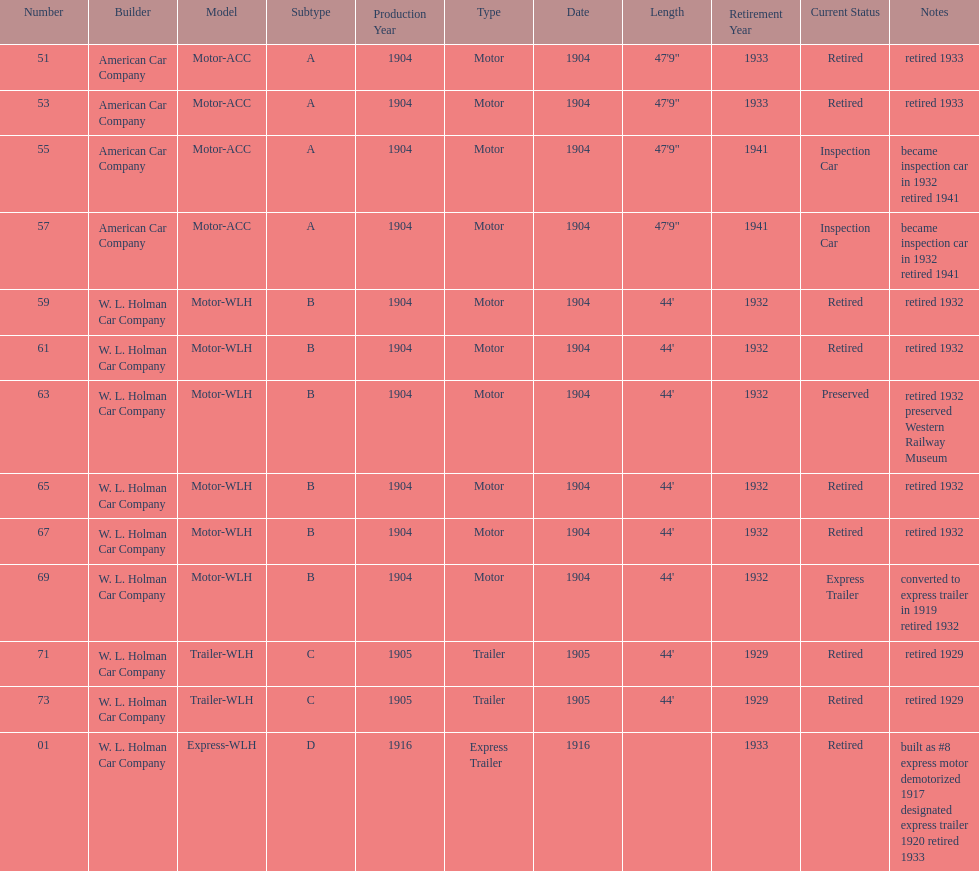Could you parse the entire table? {'header': ['Number', 'Builder', 'Model', 'Subtype', 'Production Year', 'Type', 'Date', 'Length', 'Retirement Year', 'Current Status', 'Notes'], 'rows': [['51', 'American Car Company', 'Motor-ACC', 'A', '1904', 'Motor', '1904', '47\'9"', '1933', 'Retired', 'retired 1933'], ['53', 'American Car Company', 'Motor-ACC', 'A', '1904', 'Motor', '1904', '47\'9"', '1933', 'Retired', 'retired 1933'], ['55', 'American Car Company', 'Motor-ACC', 'A', '1904', 'Motor', '1904', '47\'9"', '1941', 'Inspection Car', 'became inspection car in 1932 retired 1941'], ['57', 'American Car Company', 'Motor-ACC', 'A', '1904', 'Motor', '1904', '47\'9"', '1941', 'Inspection Car', 'became inspection car in 1932 retired 1941'], ['59', 'W. L. Holman Car Company', 'Motor-WLH', 'B', '1904', 'Motor', '1904', "44'", '1932', 'Retired', 'retired 1932'], ['61', 'W. L. Holman Car Company', 'Motor-WLH', 'B', '1904', 'Motor', '1904', "44'", '1932', 'Retired', 'retired 1932'], ['63', 'W. L. Holman Car Company', 'Motor-WLH', 'B', '1904', 'Motor', '1904', "44'", '1932', 'Preserved', 'retired 1932 preserved Western Railway Museum'], ['65', 'W. L. Holman Car Company', 'Motor-WLH', 'B', '1904', 'Motor', '1904', "44'", '1932', 'Retired', 'retired 1932'], ['67', 'W. L. Holman Car Company', 'Motor-WLH', 'B', '1904', 'Motor', '1904', "44'", '1932', 'Retired', 'retired 1932'], ['69', 'W. L. Holman Car Company', 'Motor-WLH', 'B', '1904', 'Motor', '1904', "44'", '1932', 'Express Trailer', 'converted to express trailer in 1919 retired 1932'], ['71', 'W. L. Holman Car Company', 'Trailer-WLH', 'C', '1905', 'Trailer', '1905', "44'", '1929', 'Retired', 'retired 1929'], ['73', 'W. L. Holman Car Company', 'Trailer-WLH', 'C', '1905', 'Trailer', '1905', "44'", '1929', 'Retired', 'retired 1929'], ['01', 'W. L. Holman Car Company', 'Express-WLH', 'D', '1916', 'Express Trailer', '1916', '', '1933', 'Retired', 'built as #8 express motor demotorized 1917 designated express trailer 1920 retired 1933']]} Did american car company or w.l. holman car company build cars that were 44' in length? W. L. Holman Car Company. 